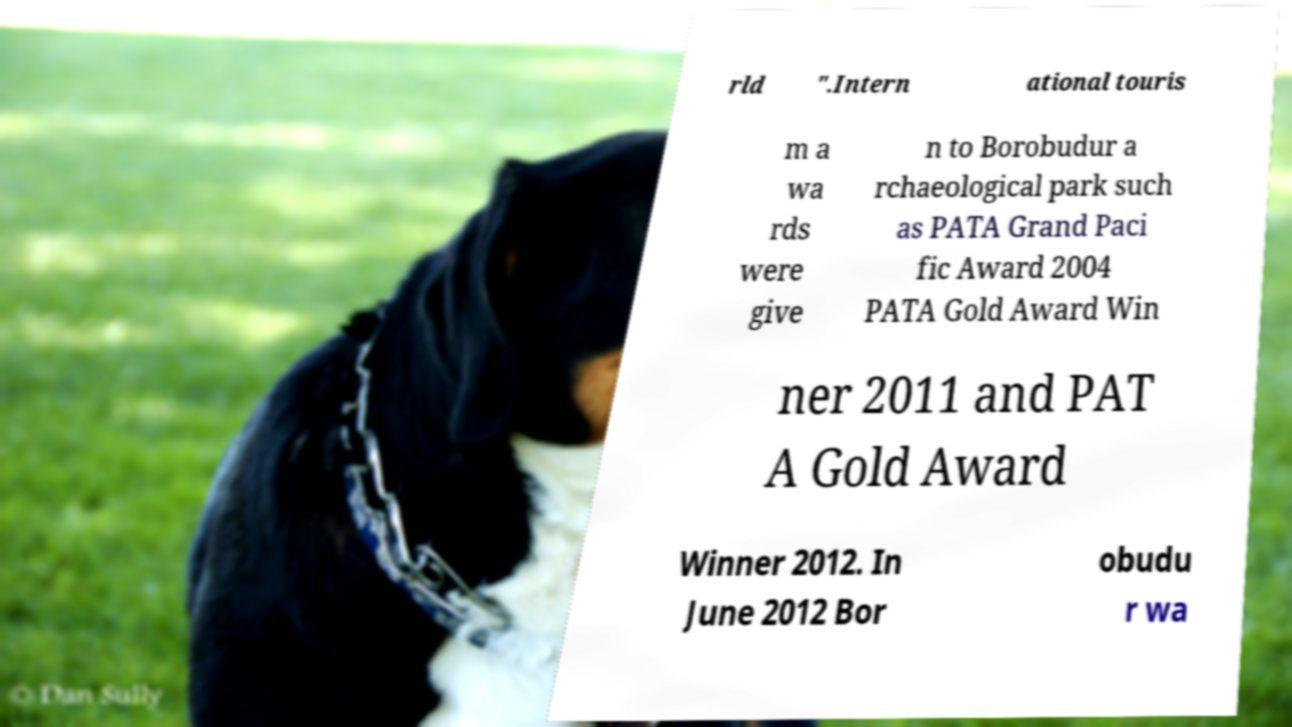Could you assist in decoding the text presented in this image and type it out clearly? rld ".Intern ational touris m a wa rds were give n to Borobudur a rchaeological park such as PATA Grand Paci fic Award 2004 PATA Gold Award Win ner 2011 and PAT A Gold Award Winner 2012. In June 2012 Bor obudu r wa 